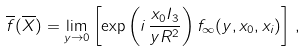<formula> <loc_0><loc_0><loc_500><loc_500>\overline { f } ( \overline { X } ) = \lim _ { y \to 0 } \left [ \exp \left ( i \, \frac { x _ { 0 } I _ { 3 } } { y R ^ { 2 } } \right ) f _ { \infty } ( y , x _ { 0 } , x _ { i } ) \right ] \, ,</formula> 